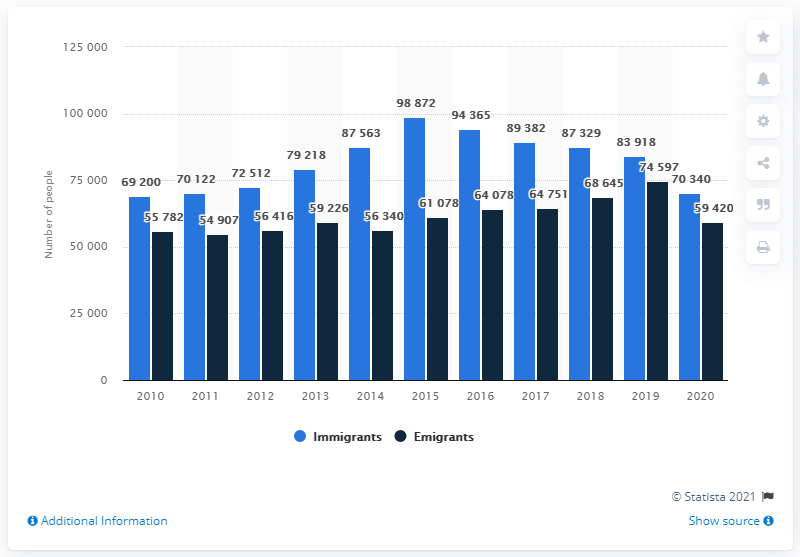Indicate a few pertinent items in this graphic. Until 2015, the number of immigrants arriving in Denmark consistently increased. In 2020, approximately 70,340 people immigrated to Denmark. 